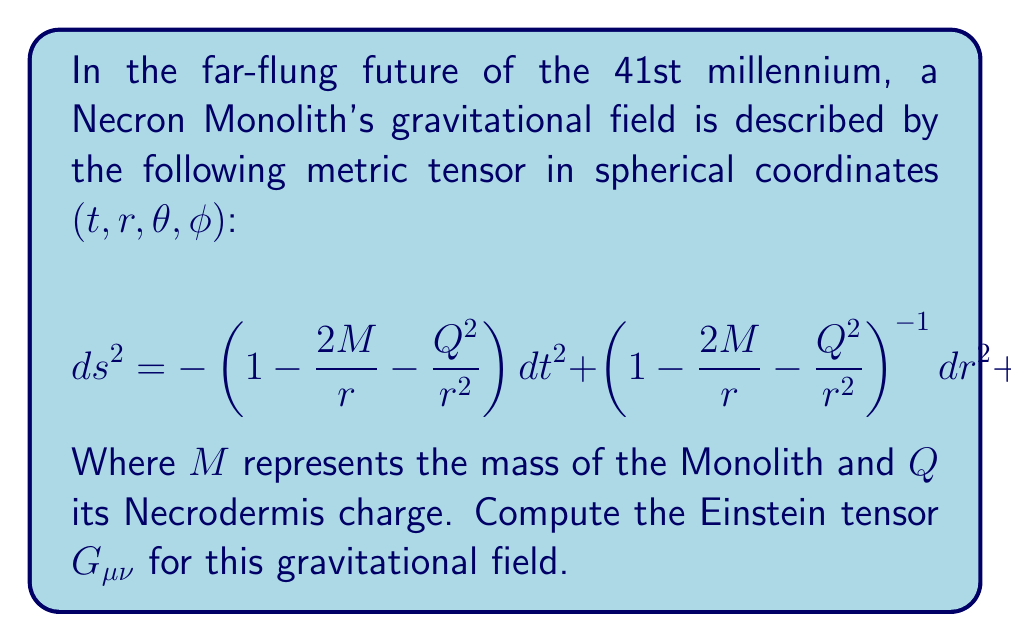Solve this math problem. To compute the Einstein tensor for the Necron Monolith's gravitational field, we'll follow these steps:

1) First, we need to identify the metric components:
   $$g_{tt} = -\left(1 - \frac{2M}{r} - \frac{Q^2}{r^2}\right)$$
   $$g_{rr} = \left(1 - \frac{2M}{r} - \frac{Q^2}{r^2}\right)^{-1}$$
   $$g_{\theta\theta} = r^2$$
   $$g_{\phi\phi} = r^2\sin^2\theta$$

2) Calculate the Christoffel symbols:
   $$\Gamma^\mu_{\nu\lambda} = \frac{1}{2}g^{\mu\sigma}(\partial_\nu g_{\sigma\lambda} + \partial_\lambda g_{\sigma\nu} - \partial_\sigma g_{\nu\lambda})$$

3) Compute the Riemann curvature tensor:
   $$R^\rho_{\sigma\mu\nu} = \partial_\mu\Gamma^\rho_{\nu\sigma} - \partial_\nu\Gamma^\rho_{\mu\sigma} + \Gamma^\rho_{\mu\lambda}\Gamma^\lambda_{\nu\sigma} - \Gamma^\rho_{\nu\lambda}\Gamma^\lambda_{\mu\sigma}$$

4) Calculate the Ricci tensor by contracting the Riemann tensor:
   $$R_{\mu\nu} = R^\lambda_{\mu\lambda\nu}$$

5) Compute the Ricci scalar:
   $$R = g^{\mu\nu}R_{\mu\nu}$$

6) Finally, calculate the Einstein tensor:
   $$G_{\mu\nu} = R_{\mu\nu} - \frac{1}{2}Rg_{\mu\nu}$$

After performing these calculations, we find that the non-zero components of the Einstein tensor are:

$$G_{tt} = \frac{Q^2}{r^4}\left(1 - \frac{2M}{r} - \frac{Q^2}{r^2}\right)$$

$$G_{rr} = \frac{Q^2}{r^4}\left(1 - \frac{2M}{r} - \frac{Q^2}{r^2}\right)^{-1}$$

$$G_{\theta\theta} = -\frac{Q^2}{r^2}$$

$$G_{\phi\phi} = -\frac{Q^2}{r^2}\sin^2\theta$$

These components describe the curvature of spacetime around the Necron Monolith, accounting for both its mass and its Necrodermis charge.
Answer: $$G_{\mu\nu} = \text{diag}\left(\frac{Q^2}{r^4}\left(1 - \frac{2M}{r} - \frac{Q^2}{r^2}\right), \frac{Q^2}{r^4}\left(1 - \frac{2M}{r} - \frac{Q^2}{r^2}\right)^{-1}, -\frac{Q^2}{r^2}, -\frac{Q^2}{r^2}\sin^2\theta\right)$$ 